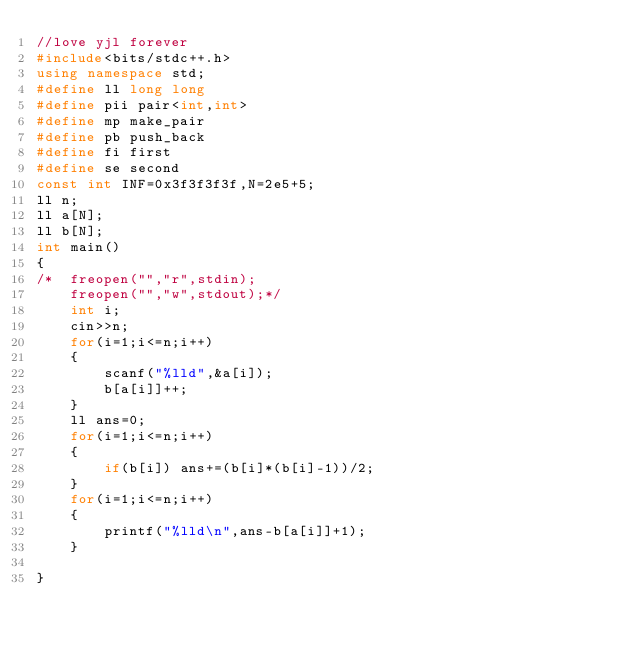<code> <loc_0><loc_0><loc_500><loc_500><_C++_>//love yjl forever
#include<bits/stdc++.h>
using namespace std;
#define ll long long 
#define pii pair<int,int>
#define mp make_pair
#define pb push_back
#define fi first
#define se second
const int INF=0x3f3f3f3f,N=2e5+5;
ll n;
ll a[N];
ll b[N];
int main()
{
/*	freopen("","r",stdin);
	freopen("","w",stdout);*/
	int i;
	cin>>n;
	for(i=1;i<=n;i++)
	{
		scanf("%lld",&a[i]);
		b[a[i]]++;
	}
	ll ans=0;
	for(i=1;i<=n;i++)
	{
		if(b[i]) ans+=(b[i]*(b[i]-1))/2;
	}
	for(i=1;i<=n;i++)
	{
		printf("%lld\n",ans-b[a[i]]+1);
	}
	
}</code> 